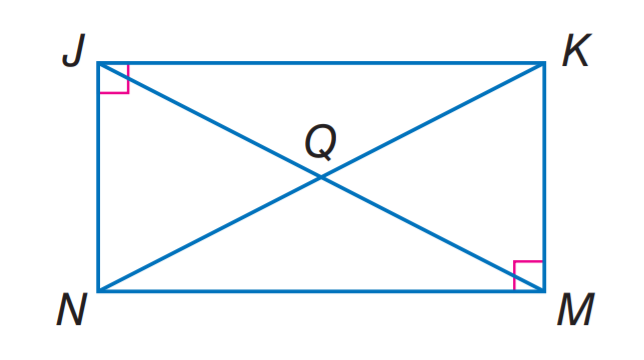Question: J K M N is a rectangle. If N Q = 2 x + 3 and Q K = 5 x - 9, find J Q.
Choices:
A. 4
B. 6
C. 9
D. 11
Answer with the letter. Answer: D 